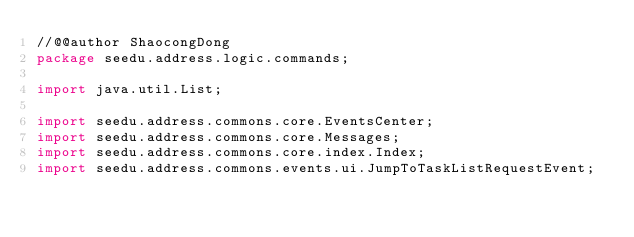Convert code to text. <code><loc_0><loc_0><loc_500><loc_500><_Java_>//@@author ShaocongDong
package seedu.address.logic.commands;

import java.util.List;

import seedu.address.commons.core.EventsCenter;
import seedu.address.commons.core.Messages;
import seedu.address.commons.core.index.Index;
import seedu.address.commons.events.ui.JumpToTaskListRequestEvent;</code> 